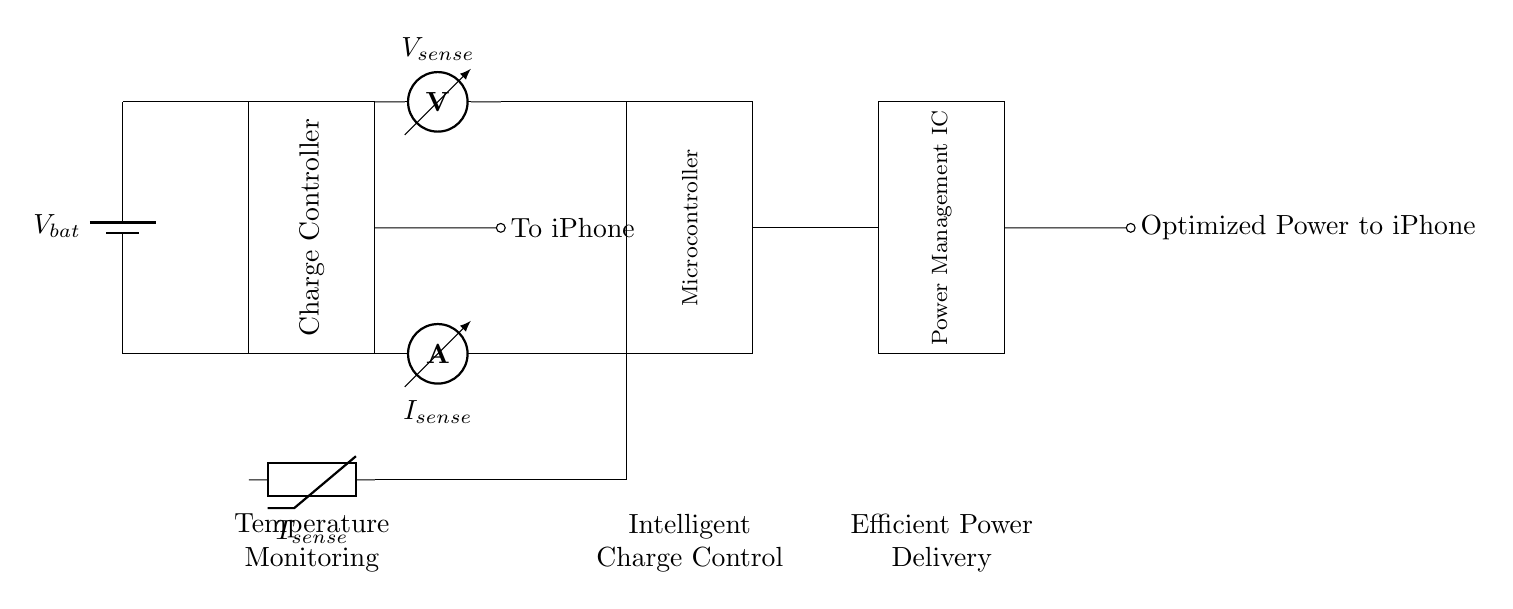What is the main purpose of the charge controller in this circuit? The charge controller regulates the charging and discharging of the battery to prevent overcharging and ensure efficient power management.
Answer: Power regulation What type of sensor is used to measure current? The ammeter is designated in the circuit as the component responsible for measuring the flow of current, represented by I_sense.
Answer: Ammeter What component is responsible for optimizing power delivery to the iPhone? The Power Management IC is specifically designed to regulate and deliver optimized power to the connected device, ensuring efficiency.
Answer: Power Management IC How many main functional blocks are present in this circuit? The circuit contains four main functional blocks: Charge Controller, Microcontroller, Power Management IC, and Temperature Sensor.
Answer: Four What is the role of the thermistor in this circuit? The thermistor is used to monitor temperature, which can help in preventing overheating during charging and improve battery health.
Answer: Temperature monitoring What is the output indication from the Power Management IC? The output from the Power Management IC is optimized power delivered to the iPhone, which indicates the efficiency of the power delivery system.
Answer: Optimized Power to iPhone 